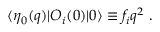<formula> <loc_0><loc_0><loc_500><loc_500>\langle \eta _ { 0 } ( q ) | O _ { i } ( 0 ) | 0 \rangle \equiv f _ { i } q ^ { 2 } \ .</formula> 